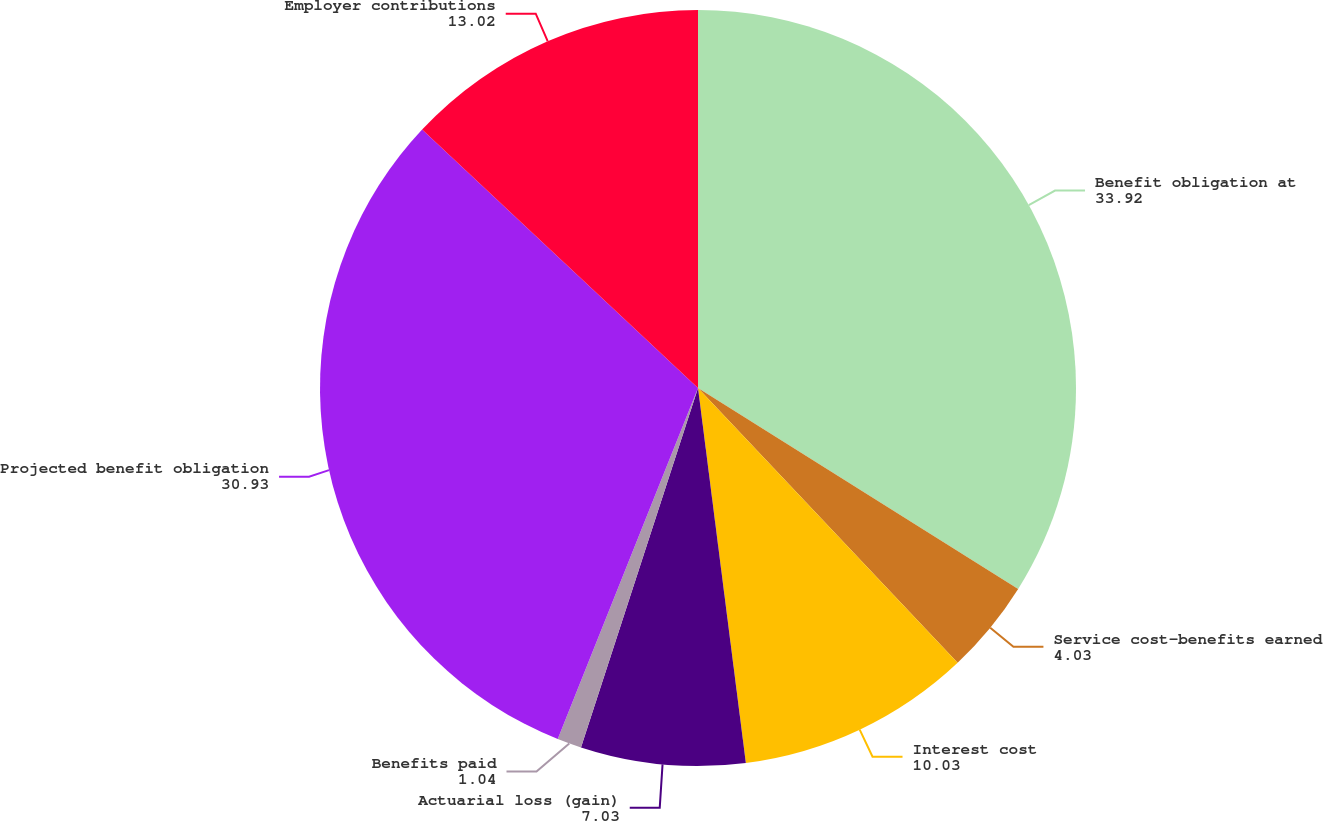Convert chart to OTSL. <chart><loc_0><loc_0><loc_500><loc_500><pie_chart><fcel>Benefit obligation at<fcel>Service cost-benefits earned<fcel>Interest cost<fcel>Actuarial loss (gain)<fcel>Benefits paid<fcel>Projected benefit obligation<fcel>Employer contributions<nl><fcel>33.92%<fcel>4.03%<fcel>10.03%<fcel>7.03%<fcel>1.04%<fcel>30.93%<fcel>13.02%<nl></chart> 